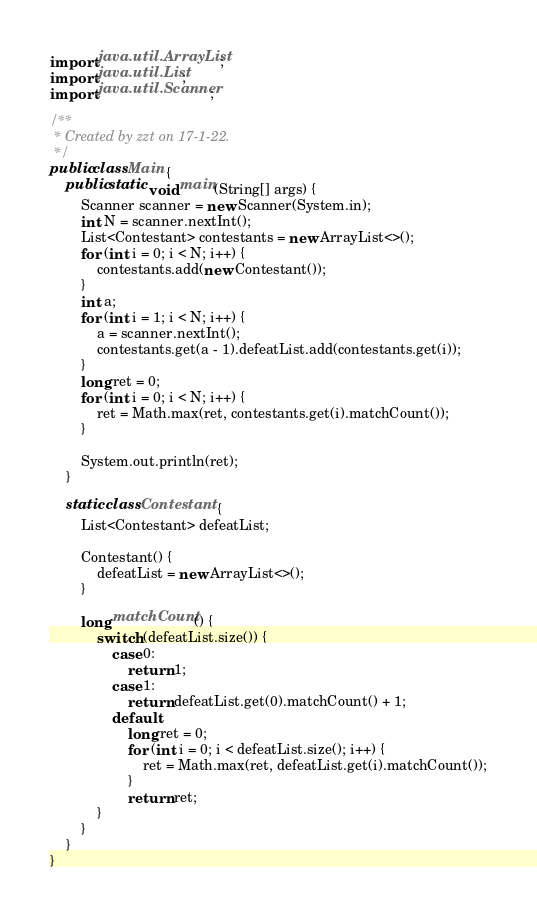<code> <loc_0><loc_0><loc_500><loc_500><_Java_>import java.util.ArrayList;
import java.util.List;
import java.util.Scanner;

/**
 * Created by zzt on 17-1-22.
 */
public class Main {
    public static void main(String[] args) {
        Scanner scanner = new Scanner(System.in);
        int N = scanner.nextInt();
        List<Contestant> contestants = new ArrayList<>();
        for (int i = 0; i < N; i++) {
            contestants.add(new Contestant());
        }
        int a;
        for (int i = 1; i < N; i++) {
            a = scanner.nextInt();
            contestants.get(a - 1).defeatList.add(contestants.get(i));
        }
        long ret = 0;
        for (int i = 0; i < N; i++) {
            ret = Math.max(ret, contestants.get(i).matchCount());
        }

        System.out.println(ret);
    }

    static class Contestant {
        List<Contestant> defeatList;

        Contestant() {
            defeatList = new ArrayList<>();
        }

        long matchCount() {
            switch (defeatList.size()) {
                case 0:
                    return 1;
                case 1:
                    return defeatList.get(0).matchCount() + 1;
                default:
                    long ret = 0;
                    for (int i = 0; i < defeatList.size(); i++) {
                        ret = Math.max(ret, defeatList.get(i).matchCount());
                    }
                    return ret;
            }
        }
    }
}</code> 